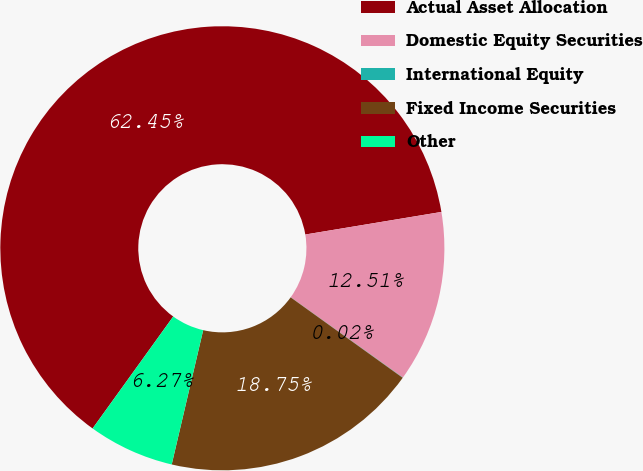<chart> <loc_0><loc_0><loc_500><loc_500><pie_chart><fcel>Actual Asset Allocation<fcel>Domestic Equity Securities<fcel>International Equity<fcel>Fixed Income Securities<fcel>Other<nl><fcel>62.45%<fcel>12.51%<fcel>0.02%<fcel>18.75%<fcel>6.27%<nl></chart> 